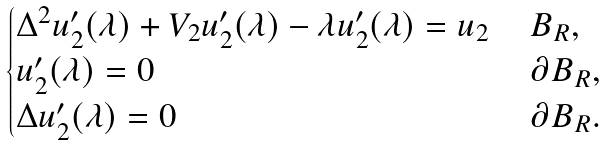Convert formula to latex. <formula><loc_0><loc_0><loc_500><loc_500>\begin{cases} \Delta ^ { 2 } u _ { 2 } ^ { \prime } ( \lambda ) + V _ { 2 } u _ { 2 } ^ { \prime } ( \lambda ) - \lambda u _ { 2 } ^ { \prime } ( \lambda ) = u _ { 2 } & \, B _ { R } , \\ u _ { 2 } ^ { \prime } ( \lambda ) = 0 & \, \partial B _ { R } , \\ \Delta u _ { 2 } ^ { \prime } ( \lambda ) = 0 & \, \partial B _ { R } . \end{cases}</formula> 